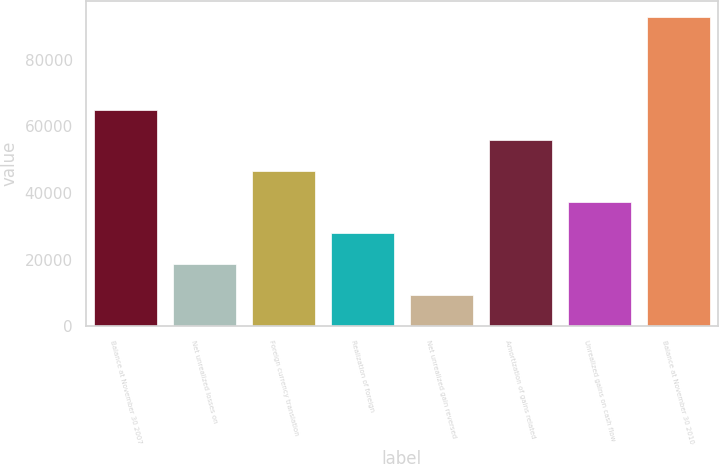Convert chart to OTSL. <chart><loc_0><loc_0><loc_500><loc_500><bar_chart><fcel>Balance at November 30 2007<fcel>Net unrealized losses on<fcel>Foreign currency translation<fcel>Realization of foreign<fcel>Net unrealized gain reversed<fcel>Amortization of gains related<fcel>Unrealized gains on cash flow<fcel>Balance at November 30 2010<nl><fcel>65096<fcel>18599.2<fcel>46497.2<fcel>27898.5<fcel>9299.8<fcel>55796.6<fcel>37197.9<fcel>92994<nl></chart> 